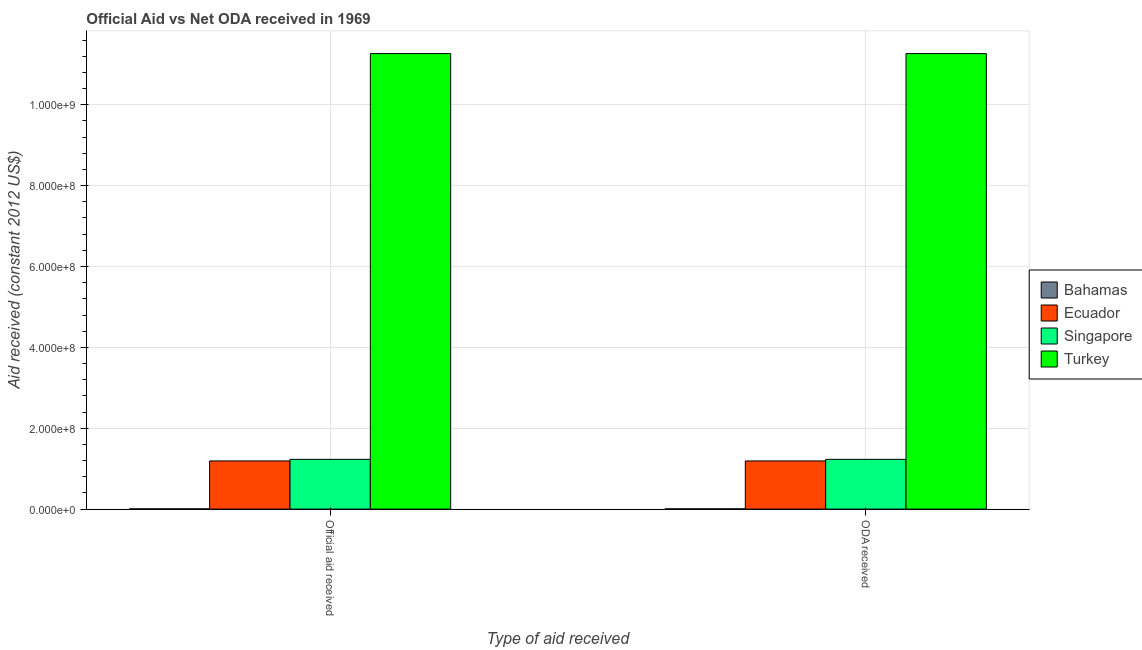How many different coloured bars are there?
Offer a very short reply. 4. How many groups of bars are there?
Make the answer very short. 2. Are the number of bars on each tick of the X-axis equal?
Offer a very short reply. Yes. How many bars are there on the 2nd tick from the right?
Offer a terse response. 4. What is the label of the 1st group of bars from the left?
Your response must be concise. Official aid received. What is the oda received in Singapore?
Offer a terse response. 1.23e+08. Across all countries, what is the maximum official aid received?
Provide a short and direct response. 1.13e+09. Across all countries, what is the minimum oda received?
Your response must be concise. 5.30e+05. In which country was the oda received maximum?
Offer a very short reply. Turkey. In which country was the oda received minimum?
Provide a succinct answer. Bahamas. What is the total official aid received in the graph?
Offer a very short reply. 1.37e+09. What is the difference between the oda received in Ecuador and that in Singapore?
Provide a short and direct response. -3.95e+06. What is the difference between the oda received in Bahamas and the official aid received in Singapore?
Offer a terse response. -1.23e+08. What is the average oda received per country?
Offer a very short reply. 3.42e+08. What is the difference between the oda received and official aid received in Turkey?
Provide a succinct answer. 0. What is the ratio of the oda received in Turkey to that in Singapore?
Provide a succinct answer. 9.16. Is the oda received in Ecuador less than that in Turkey?
Keep it short and to the point. Yes. In how many countries, is the oda received greater than the average oda received taken over all countries?
Keep it short and to the point. 1. What does the 2nd bar from the left in Official aid received represents?
Offer a terse response. Ecuador. What does the 4th bar from the right in Official aid received represents?
Ensure brevity in your answer.  Bahamas. How many countries are there in the graph?
Keep it short and to the point. 4. What is the difference between two consecutive major ticks on the Y-axis?
Offer a very short reply. 2.00e+08. Are the values on the major ticks of Y-axis written in scientific E-notation?
Keep it short and to the point. Yes. Does the graph contain any zero values?
Provide a succinct answer. No. Does the graph contain grids?
Give a very brief answer. Yes. How many legend labels are there?
Offer a very short reply. 4. How are the legend labels stacked?
Ensure brevity in your answer.  Vertical. What is the title of the graph?
Make the answer very short. Official Aid vs Net ODA received in 1969 . Does "Middle income" appear as one of the legend labels in the graph?
Provide a succinct answer. No. What is the label or title of the X-axis?
Keep it short and to the point. Type of aid received. What is the label or title of the Y-axis?
Offer a terse response. Aid received (constant 2012 US$). What is the Aid received (constant 2012 US$) in Bahamas in Official aid received?
Make the answer very short. 5.30e+05. What is the Aid received (constant 2012 US$) in Ecuador in Official aid received?
Ensure brevity in your answer.  1.19e+08. What is the Aid received (constant 2012 US$) of Singapore in Official aid received?
Your answer should be very brief. 1.23e+08. What is the Aid received (constant 2012 US$) in Turkey in Official aid received?
Provide a succinct answer. 1.13e+09. What is the Aid received (constant 2012 US$) of Bahamas in ODA received?
Make the answer very short. 5.30e+05. What is the Aid received (constant 2012 US$) in Ecuador in ODA received?
Offer a very short reply. 1.19e+08. What is the Aid received (constant 2012 US$) of Singapore in ODA received?
Offer a terse response. 1.23e+08. What is the Aid received (constant 2012 US$) of Turkey in ODA received?
Offer a very short reply. 1.13e+09. Across all Type of aid received, what is the maximum Aid received (constant 2012 US$) in Bahamas?
Your answer should be compact. 5.30e+05. Across all Type of aid received, what is the maximum Aid received (constant 2012 US$) in Ecuador?
Provide a short and direct response. 1.19e+08. Across all Type of aid received, what is the maximum Aid received (constant 2012 US$) of Singapore?
Provide a succinct answer. 1.23e+08. Across all Type of aid received, what is the maximum Aid received (constant 2012 US$) in Turkey?
Your response must be concise. 1.13e+09. Across all Type of aid received, what is the minimum Aid received (constant 2012 US$) of Bahamas?
Your answer should be compact. 5.30e+05. Across all Type of aid received, what is the minimum Aid received (constant 2012 US$) of Ecuador?
Provide a short and direct response. 1.19e+08. Across all Type of aid received, what is the minimum Aid received (constant 2012 US$) in Singapore?
Make the answer very short. 1.23e+08. Across all Type of aid received, what is the minimum Aid received (constant 2012 US$) of Turkey?
Make the answer very short. 1.13e+09. What is the total Aid received (constant 2012 US$) of Bahamas in the graph?
Ensure brevity in your answer.  1.06e+06. What is the total Aid received (constant 2012 US$) in Ecuador in the graph?
Keep it short and to the point. 2.38e+08. What is the total Aid received (constant 2012 US$) of Singapore in the graph?
Provide a succinct answer. 2.46e+08. What is the total Aid received (constant 2012 US$) in Turkey in the graph?
Give a very brief answer. 2.25e+09. What is the difference between the Aid received (constant 2012 US$) in Bahamas in Official aid received and that in ODA received?
Give a very brief answer. 0. What is the difference between the Aid received (constant 2012 US$) in Singapore in Official aid received and that in ODA received?
Provide a short and direct response. 0. What is the difference between the Aid received (constant 2012 US$) in Turkey in Official aid received and that in ODA received?
Keep it short and to the point. 0. What is the difference between the Aid received (constant 2012 US$) of Bahamas in Official aid received and the Aid received (constant 2012 US$) of Ecuador in ODA received?
Your answer should be compact. -1.19e+08. What is the difference between the Aid received (constant 2012 US$) of Bahamas in Official aid received and the Aid received (constant 2012 US$) of Singapore in ODA received?
Your answer should be very brief. -1.23e+08. What is the difference between the Aid received (constant 2012 US$) in Bahamas in Official aid received and the Aid received (constant 2012 US$) in Turkey in ODA received?
Your answer should be very brief. -1.13e+09. What is the difference between the Aid received (constant 2012 US$) of Ecuador in Official aid received and the Aid received (constant 2012 US$) of Singapore in ODA received?
Give a very brief answer. -3.95e+06. What is the difference between the Aid received (constant 2012 US$) of Ecuador in Official aid received and the Aid received (constant 2012 US$) of Turkey in ODA received?
Keep it short and to the point. -1.01e+09. What is the difference between the Aid received (constant 2012 US$) of Singapore in Official aid received and the Aid received (constant 2012 US$) of Turkey in ODA received?
Offer a terse response. -1.00e+09. What is the average Aid received (constant 2012 US$) in Bahamas per Type of aid received?
Provide a succinct answer. 5.30e+05. What is the average Aid received (constant 2012 US$) in Ecuador per Type of aid received?
Give a very brief answer. 1.19e+08. What is the average Aid received (constant 2012 US$) of Singapore per Type of aid received?
Offer a terse response. 1.23e+08. What is the average Aid received (constant 2012 US$) in Turkey per Type of aid received?
Keep it short and to the point. 1.13e+09. What is the difference between the Aid received (constant 2012 US$) of Bahamas and Aid received (constant 2012 US$) of Ecuador in Official aid received?
Your answer should be compact. -1.19e+08. What is the difference between the Aid received (constant 2012 US$) in Bahamas and Aid received (constant 2012 US$) in Singapore in Official aid received?
Offer a very short reply. -1.23e+08. What is the difference between the Aid received (constant 2012 US$) of Bahamas and Aid received (constant 2012 US$) of Turkey in Official aid received?
Ensure brevity in your answer.  -1.13e+09. What is the difference between the Aid received (constant 2012 US$) of Ecuador and Aid received (constant 2012 US$) of Singapore in Official aid received?
Offer a very short reply. -3.95e+06. What is the difference between the Aid received (constant 2012 US$) in Ecuador and Aid received (constant 2012 US$) in Turkey in Official aid received?
Your answer should be compact. -1.01e+09. What is the difference between the Aid received (constant 2012 US$) of Singapore and Aid received (constant 2012 US$) of Turkey in Official aid received?
Make the answer very short. -1.00e+09. What is the difference between the Aid received (constant 2012 US$) in Bahamas and Aid received (constant 2012 US$) in Ecuador in ODA received?
Make the answer very short. -1.19e+08. What is the difference between the Aid received (constant 2012 US$) in Bahamas and Aid received (constant 2012 US$) in Singapore in ODA received?
Your answer should be compact. -1.23e+08. What is the difference between the Aid received (constant 2012 US$) of Bahamas and Aid received (constant 2012 US$) of Turkey in ODA received?
Keep it short and to the point. -1.13e+09. What is the difference between the Aid received (constant 2012 US$) of Ecuador and Aid received (constant 2012 US$) of Singapore in ODA received?
Offer a very short reply. -3.95e+06. What is the difference between the Aid received (constant 2012 US$) of Ecuador and Aid received (constant 2012 US$) of Turkey in ODA received?
Ensure brevity in your answer.  -1.01e+09. What is the difference between the Aid received (constant 2012 US$) in Singapore and Aid received (constant 2012 US$) in Turkey in ODA received?
Provide a succinct answer. -1.00e+09. What is the ratio of the Aid received (constant 2012 US$) in Singapore in Official aid received to that in ODA received?
Offer a terse response. 1. What is the ratio of the Aid received (constant 2012 US$) of Turkey in Official aid received to that in ODA received?
Provide a short and direct response. 1. What is the difference between the highest and the second highest Aid received (constant 2012 US$) in Ecuador?
Ensure brevity in your answer.  0. What is the difference between the highest and the second highest Aid received (constant 2012 US$) in Singapore?
Your answer should be compact. 0. What is the difference between the highest and the lowest Aid received (constant 2012 US$) in Bahamas?
Offer a very short reply. 0. What is the difference between the highest and the lowest Aid received (constant 2012 US$) in Turkey?
Make the answer very short. 0. 